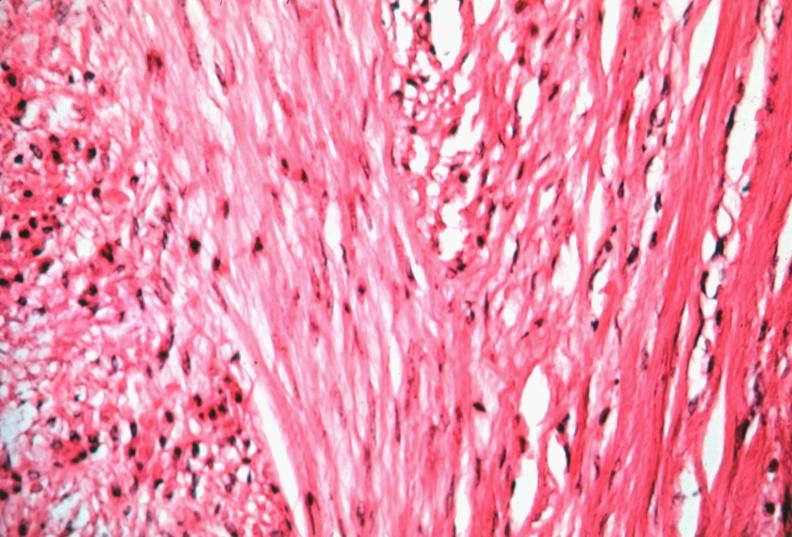does leiomyoma show uterus, leiomyoma?
Answer the question using a single word or phrase. No 